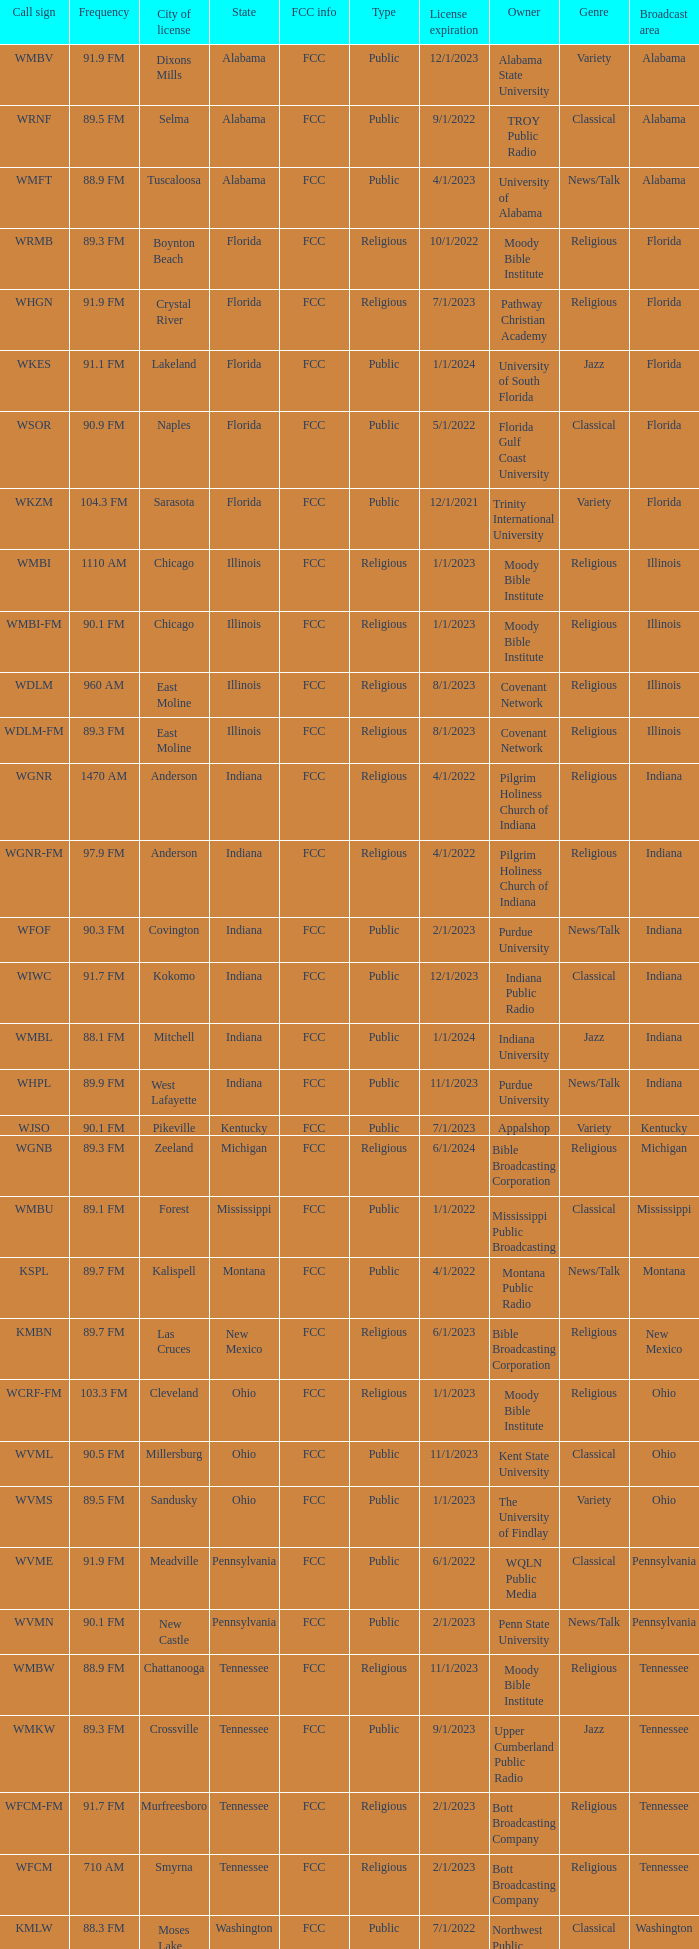What city is 103.3 FM licensed in? Cleveland. 